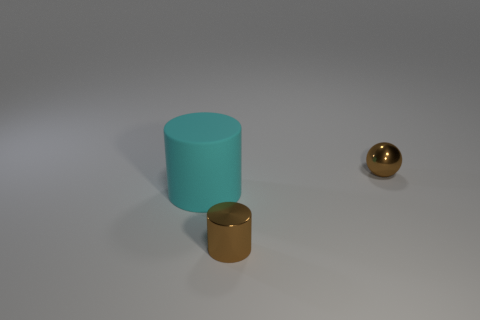How many small balls have the same color as the small metallic cylinder?
Offer a terse response. 1. What material is the tiny thing that is the same color as the small sphere?
Provide a succinct answer. Metal. What shape is the tiny shiny thing that is the same color as the tiny ball?
Make the answer very short. Cylinder. There is a thing that is the same color as the tiny cylinder; what size is it?
Your answer should be very brief. Small. How big is the object that is both right of the matte thing and behind the shiny cylinder?
Give a very brief answer. Small. What is the color of the other metal thing that is the same shape as the large cyan thing?
Your answer should be very brief. Brown. Are there more objects that are on the right side of the large thing than brown metallic things that are left of the brown cylinder?
Offer a very short reply. Yes. How many other things are the same shape as the big thing?
Your answer should be very brief. 1. There is a shiny thing that is in front of the large cyan object; is there a cyan matte object that is behind it?
Your response must be concise. Yes. What number of big gray matte cubes are there?
Keep it short and to the point. 0. 